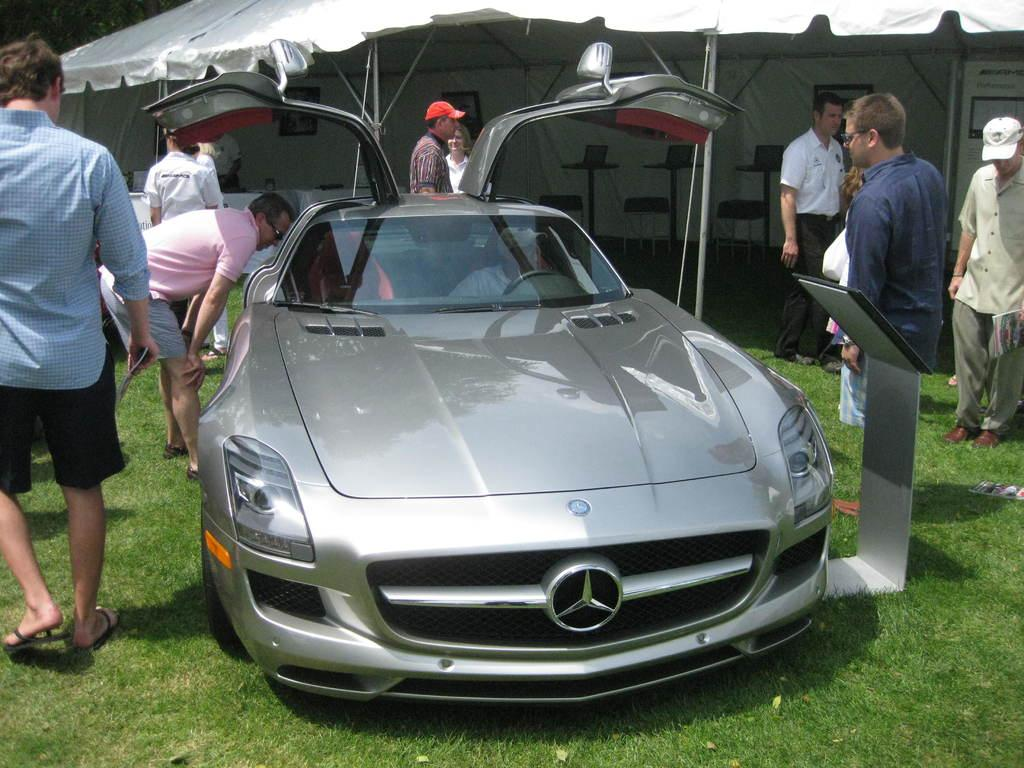Who or what can be seen in the image? There are people in the image. What objects are present that the people might sit on? There are chairs in the image. What mode of transportation is visible in the image? There is a car in the image. What type of shelter is present in the image? There is a tent in the image. What type of ground surface is visible in the image? Grass is present in the image. What card game are the people playing in the image? There is no card game present in the image; it features people, chairs, a car, a tent, and grass. 